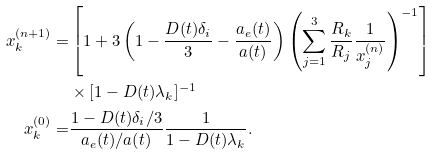<formula> <loc_0><loc_0><loc_500><loc_500>x _ { k } ^ { ( n + 1 ) } = & \left [ 1 + 3 \left ( 1 - \frac { D ( t ) \delta _ { i } } { 3 } - \frac { a _ { e } ( t ) } { a ( t ) } \right ) \left ( \sum _ { j = 1 } ^ { 3 } \frac { R _ { k } } { R _ { j } } \frac { 1 } { x _ { j } ^ { ( n ) } } \right ) ^ { - 1 } \right ] \\ & \times [ 1 - D ( t ) \lambda _ { k } ] ^ { - 1 } \\ x _ { k } ^ { ( 0 ) } = & \frac { 1 - D ( t ) \delta _ { i } / 3 } { a _ { e } ( t ) / a ( t ) } \frac { 1 } { 1 - D ( t ) \lambda _ { k } } .</formula> 